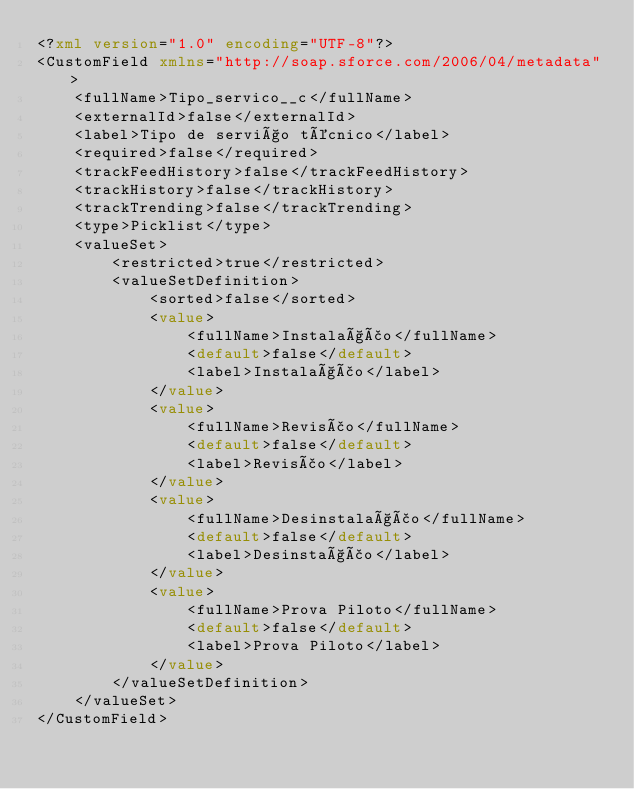<code> <loc_0><loc_0><loc_500><loc_500><_XML_><?xml version="1.0" encoding="UTF-8"?>
<CustomField xmlns="http://soap.sforce.com/2006/04/metadata">
    <fullName>Tipo_servico__c</fullName>
    <externalId>false</externalId>
    <label>Tipo de serviço técnico</label>
    <required>false</required>
    <trackFeedHistory>false</trackFeedHistory>
    <trackHistory>false</trackHistory>
    <trackTrending>false</trackTrending>
    <type>Picklist</type>
    <valueSet>
        <restricted>true</restricted>
        <valueSetDefinition>
            <sorted>false</sorted>
            <value>
                <fullName>Instalação</fullName>
                <default>false</default>
                <label>Instalação</label>
            </value>
            <value>
                <fullName>Revisão</fullName>
                <default>false</default>
                <label>Revisão</label>
            </value>
            <value>
                <fullName>Desinstalação</fullName>
                <default>false</default>
                <label>Desinstação</label>
            </value>
            <value>
                <fullName>Prova Piloto</fullName>
                <default>false</default>
                <label>Prova Piloto</label>
            </value>
        </valueSetDefinition>
    </valueSet>
</CustomField>
</code> 